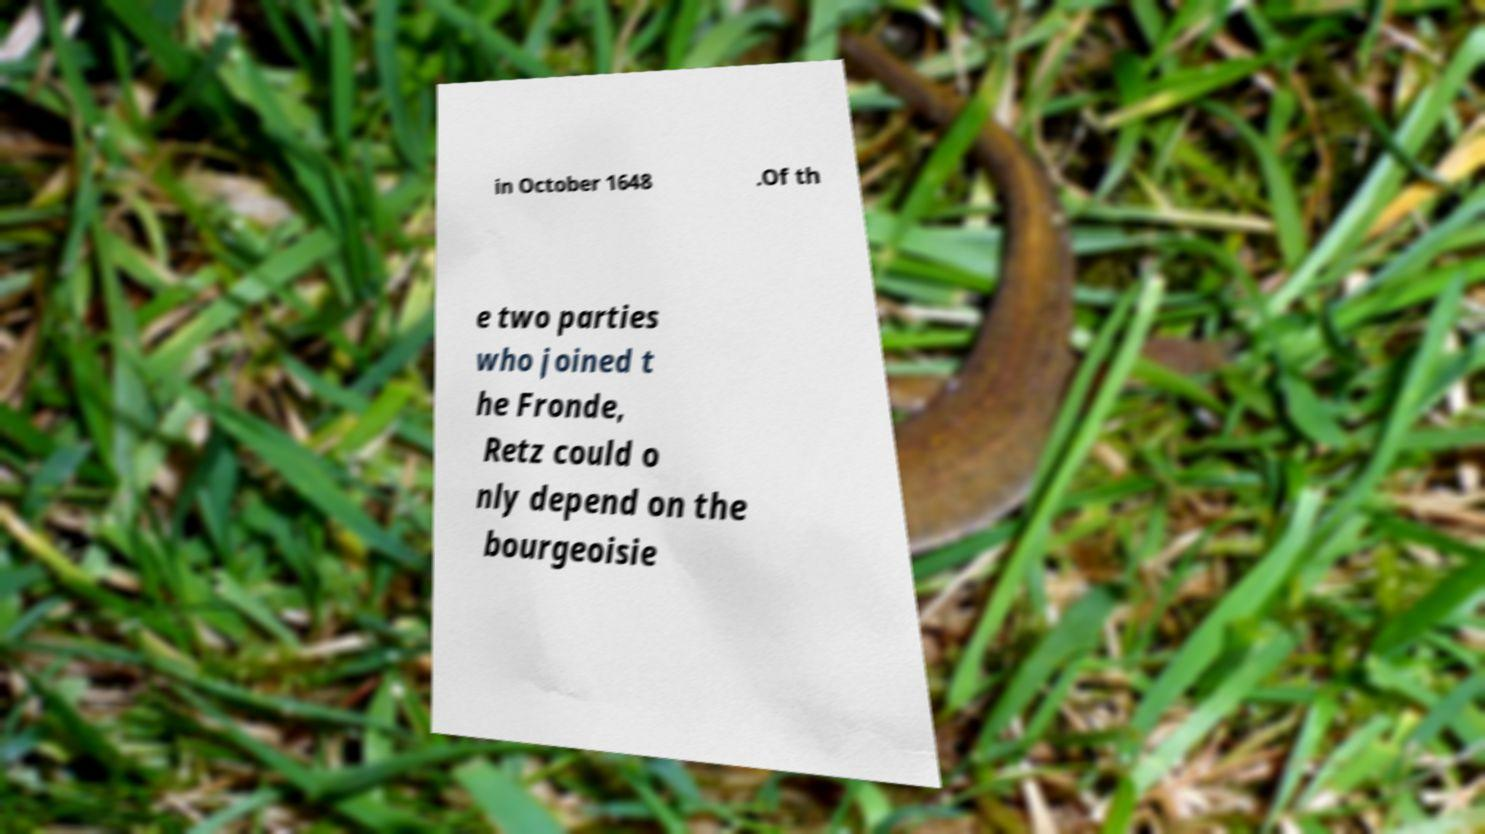What messages or text are displayed in this image? I need them in a readable, typed format. in October 1648 .Of th e two parties who joined t he Fronde, Retz could o nly depend on the bourgeoisie 